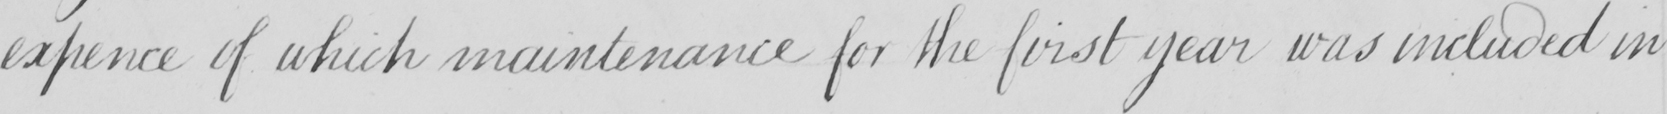What text is written in this handwritten line? expence of which maintenance for the first year was included in 